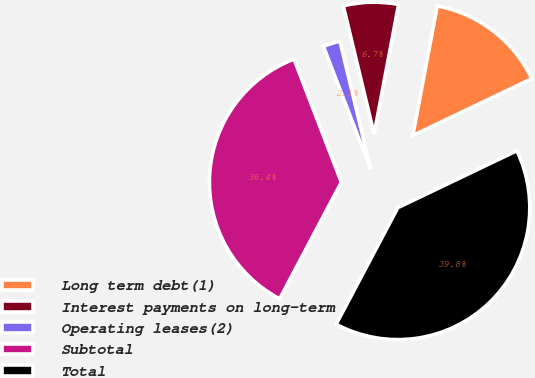Convert chart to OTSL. <chart><loc_0><loc_0><loc_500><loc_500><pie_chart><fcel>Long term debt(1)<fcel>Interest payments on long-term<fcel>Operating leases(2)<fcel>Subtotal<fcel>Total<nl><fcel>14.93%<fcel>6.72%<fcel>2.09%<fcel>36.41%<fcel>39.85%<nl></chart> 